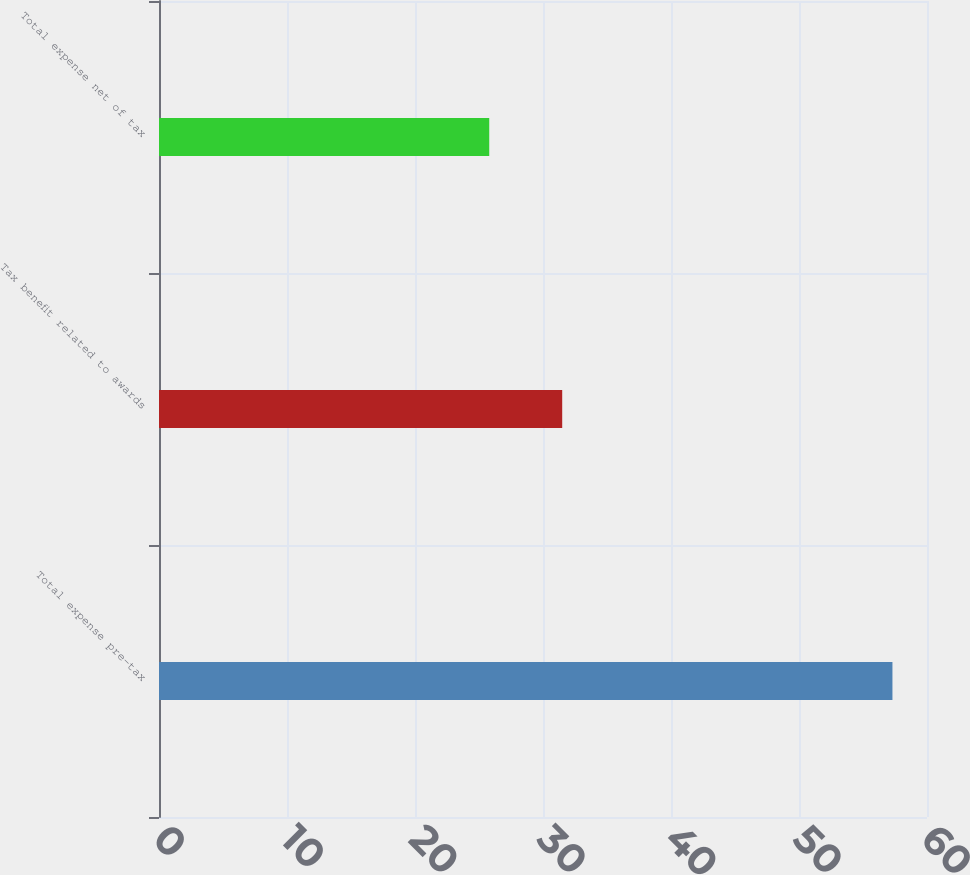<chart> <loc_0><loc_0><loc_500><loc_500><bar_chart><fcel>Total expense pre-tax<fcel>Tax benefit related to awards<fcel>Total expense net of tax<nl><fcel>57.3<fcel>31.5<fcel>25.8<nl></chart> 